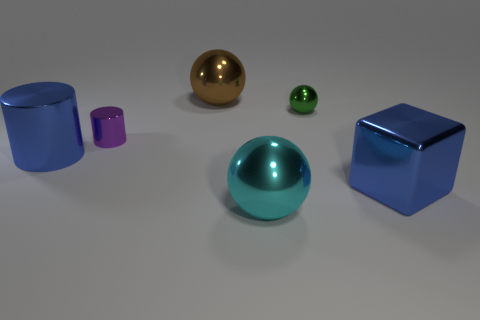Add 1 large brown shiny spheres. How many objects exist? 7 Subtract all large shiny spheres. How many spheres are left? 1 Subtract 2 balls. How many balls are left? 1 Subtract all cylinders. How many objects are left? 4 Subtract all cyan spheres. How many spheres are left? 2 Subtract 0 green cubes. How many objects are left? 6 Subtract all yellow cylinders. Subtract all red cubes. How many cylinders are left? 2 Subtract all cyan metallic things. Subtract all blue objects. How many objects are left? 3 Add 1 small purple shiny things. How many small purple shiny things are left? 2 Add 4 cubes. How many cubes exist? 5 